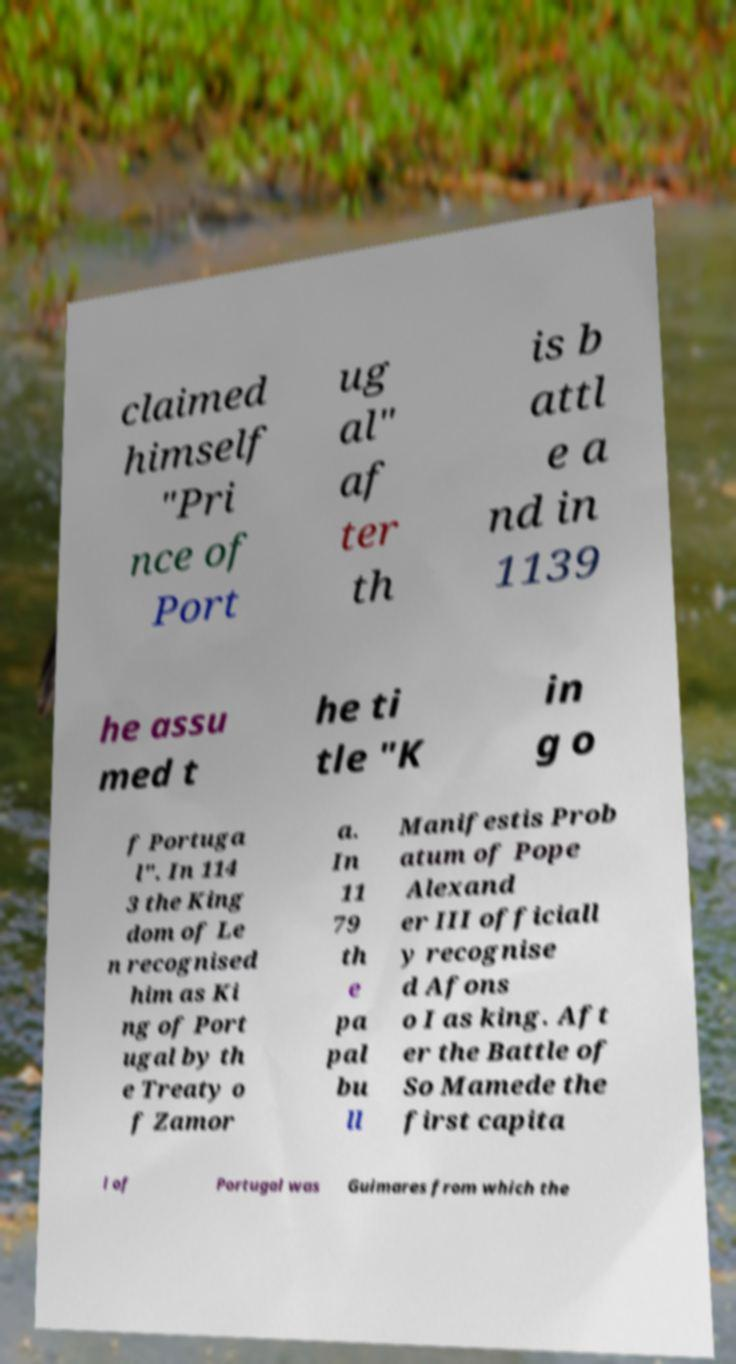Could you assist in decoding the text presented in this image and type it out clearly? claimed himself "Pri nce of Port ug al" af ter th is b attl e a nd in 1139 he assu med t he ti tle "K in g o f Portuga l". In 114 3 the King dom of Le n recognised him as Ki ng of Port ugal by th e Treaty o f Zamor a. In 11 79 th e pa pal bu ll Manifestis Prob atum of Pope Alexand er III officiall y recognise d Afons o I as king. Aft er the Battle of So Mamede the first capita l of Portugal was Guimares from which the 